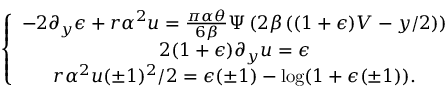<formula> <loc_0><loc_0><loc_500><loc_500>\left \{ \begin{array} { c } { - 2 \partial _ { y } \epsilon + r \alpha ^ { 2 } u = \frac { \pi \alpha \theta } { 6 \beta } \Psi \left ( 2 \beta \left ( ( 1 + \epsilon ) V - y / 2 \right ) \right ) } \\ { 2 ( 1 + \epsilon ) \partial _ { y } u = \epsilon } \\ { r \alpha ^ { 2 } u ( \pm 1 ) ^ { 2 } / 2 = \epsilon ( \pm 1 ) - \log ( 1 + \epsilon ( \pm 1 ) ) . } \end{array}</formula> 